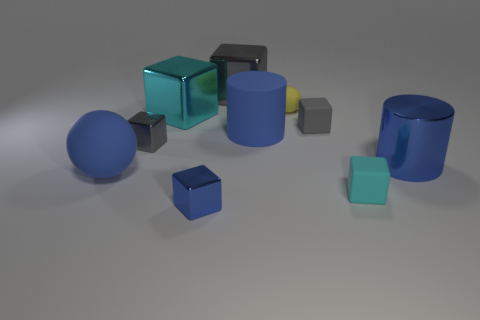Subtract all brown cylinders. How many cyan blocks are left? 2 Subtract all gray blocks. How many blocks are left? 3 Subtract all blue cubes. How many cubes are left? 5 Subtract all cubes. How many objects are left? 4 Subtract 1 gray blocks. How many objects are left? 9 Subtract all purple blocks. Subtract all green spheres. How many blocks are left? 6 Subtract all balls. Subtract all big blue spheres. How many objects are left? 7 Add 6 gray metallic things. How many gray metallic things are left? 8 Add 6 large green metallic blocks. How many large green metallic blocks exist? 6 